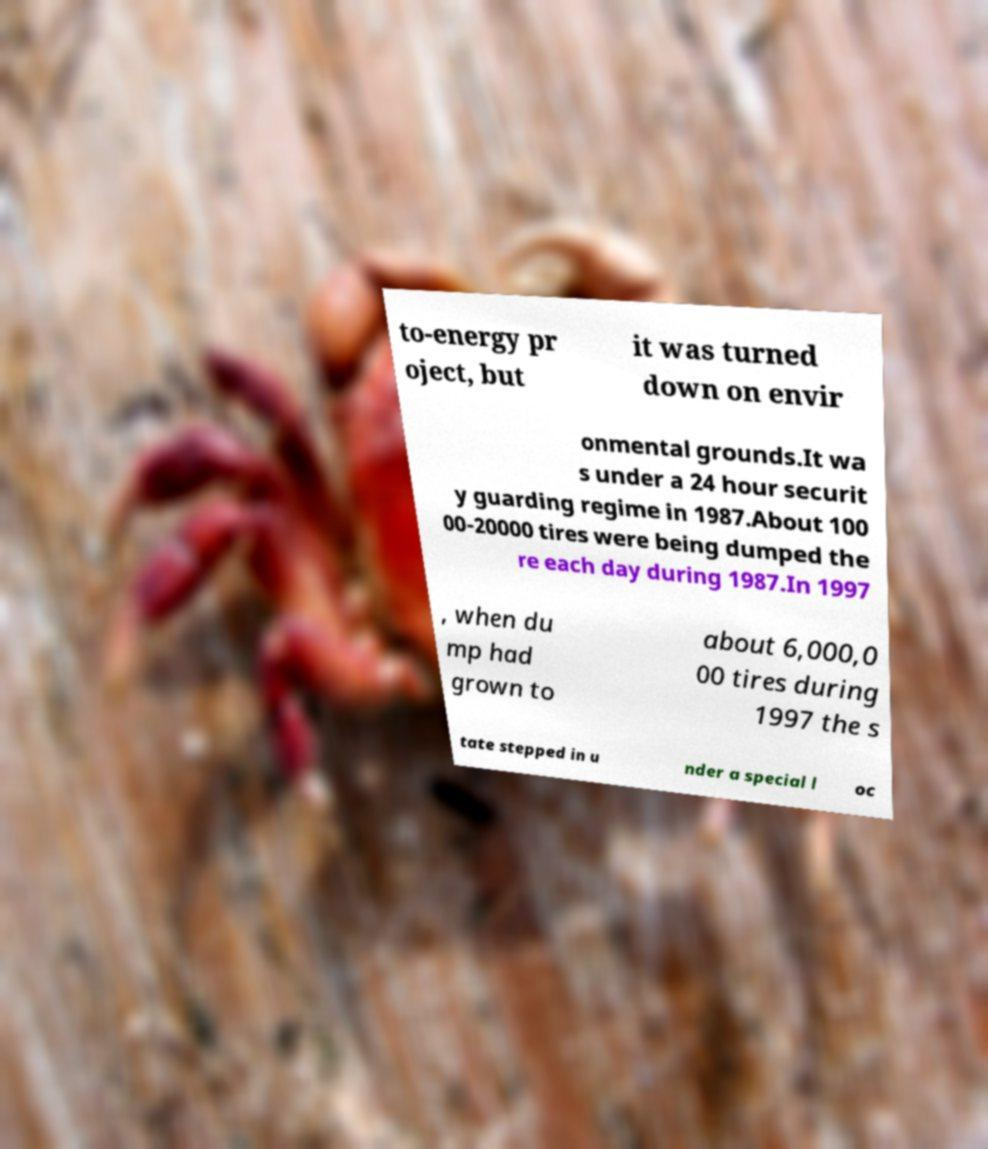Could you assist in decoding the text presented in this image and type it out clearly? to-energy pr oject, but it was turned down on envir onmental grounds.It wa s under a 24 hour securit y guarding regime in 1987.About 100 00-20000 tires were being dumped the re each day during 1987.In 1997 , when du mp had grown to about 6,000,0 00 tires during 1997 the s tate stepped in u nder a special l oc 